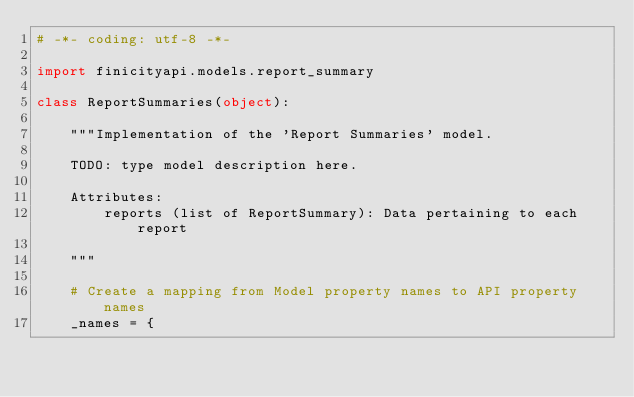Convert code to text. <code><loc_0><loc_0><loc_500><loc_500><_Python_># -*- coding: utf-8 -*-

import finicityapi.models.report_summary

class ReportSummaries(object):

    """Implementation of the 'Report Summaries' model.

    TODO: type model description here.

    Attributes:
        reports (list of ReportSummary): Data pertaining to each report

    """

    # Create a mapping from Model property names to API property names
    _names = {</code> 